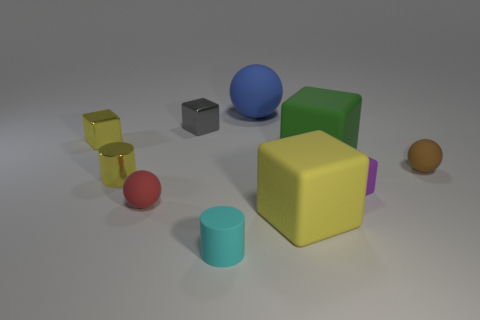How do the surface textures of the objects compare? The objects in the image display a variety of surface textures. The yellow block in the foreground has a smooth, matte finish, whereas the red sphere to its left has a glossy appearance. The large green object in the back also has a matte facade, much like the yellow block. These differences in texture suggest the materials are distinct or that they've been treated to exhibit different reflective qualities. 